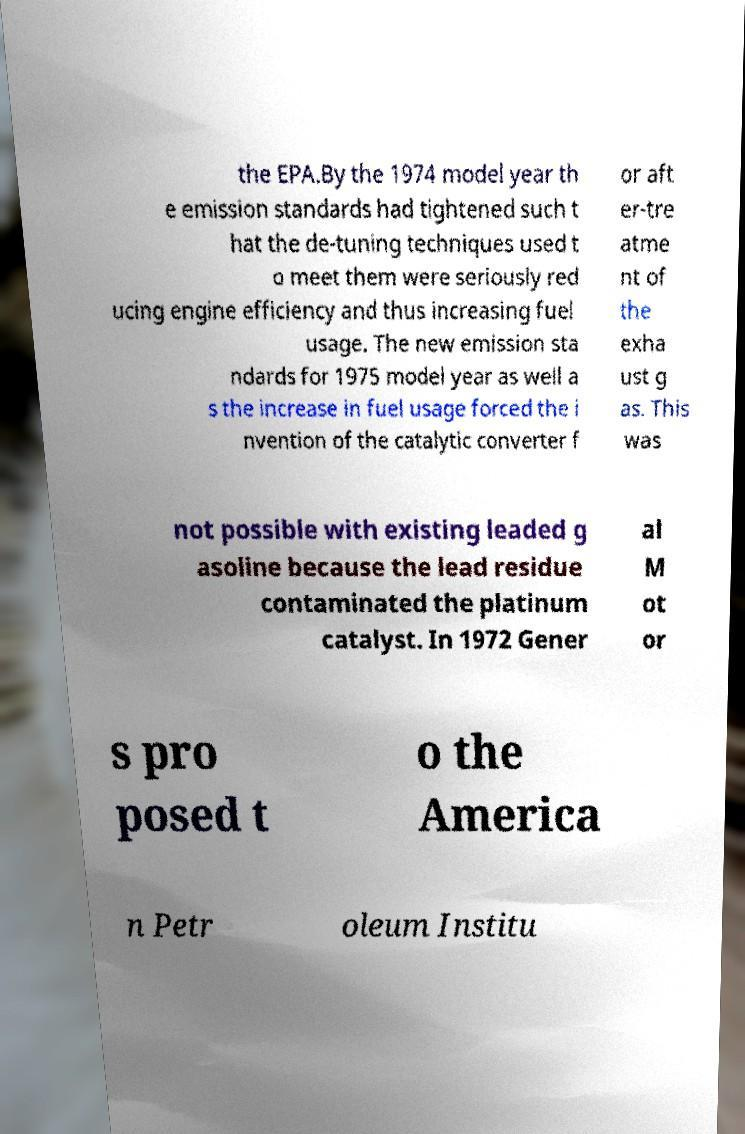Could you assist in decoding the text presented in this image and type it out clearly? the EPA.By the 1974 model year th e emission standards had tightened such t hat the de-tuning techniques used t o meet them were seriously red ucing engine efficiency and thus increasing fuel usage. The new emission sta ndards for 1975 model year as well a s the increase in fuel usage forced the i nvention of the catalytic converter f or aft er-tre atme nt of the exha ust g as. This was not possible with existing leaded g asoline because the lead residue contaminated the platinum catalyst. In 1972 Gener al M ot or s pro posed t o the America n Petr oleum Institu 